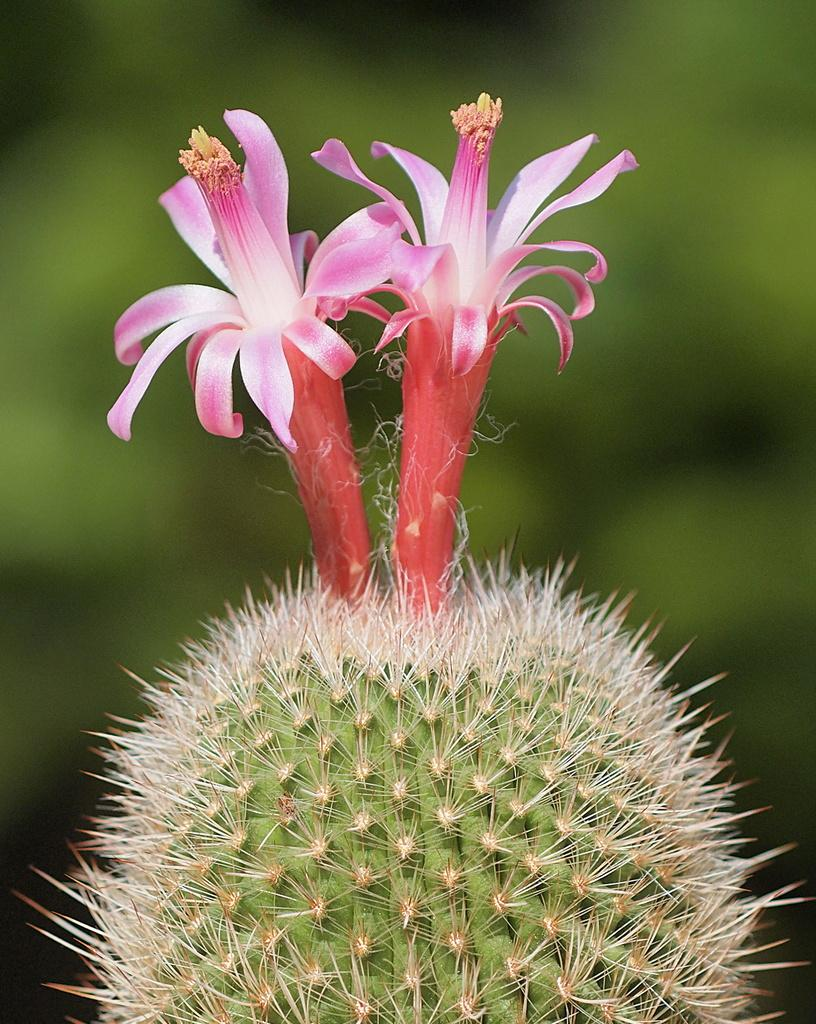What is present in the image? There is a plant in the image. Can you describe the flowers on the plant? The plant has two pink flowers on top. What type of lead can be seen connecting the plant to the can? There is no lead or can present in the image; it only features a plant with two pink flowers. What color is the yarn used to decorate the plant? There is no yarn present in the image; the plant only has two pink flowers. 